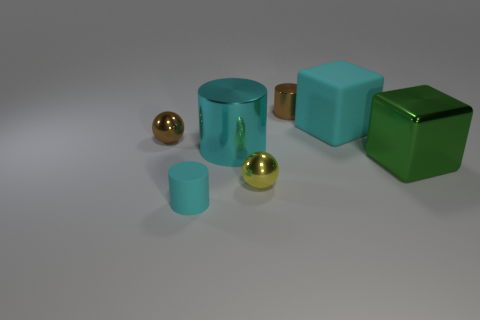Subtract all big metal cylinders. How many cylinders are left? 2 Subtract all cyan cylinders. How many cylinders are left? 1 Subtract all cylinders. How many objects are left? 4 Add 3 small balls. How many objects exist? 10 Subtract all small yellow matte things. Subtract all green metal cubes. How many objects are left? 6 Add 3 brown spheres. How many brown spheres are left? 4 Add 1 small brown cylinders. How many small brown cylinders exist? 2 Subtract 0 yellow cylinders. How many objects are left? 7 Subtract 1 cubes. How many cubes are left? 1 Subtract all green spheres. Subtract all cyan cylinders. How many spheres are left? 2 